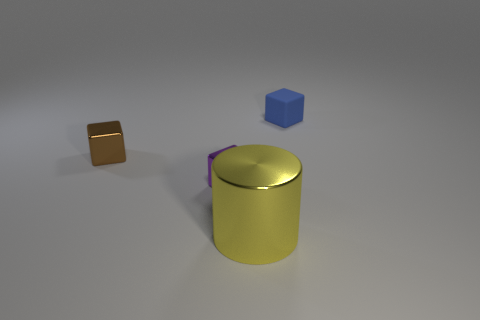Add 2 brown matte things. How many objects exist? 6 Subtract all blocks. How many objects are left? 1 Add 4 tiny shiny objects. How many tiny shiny objects are left? 6 Add 4 small cubes. How many small cubes exist? 7 Subtract 1 purple cubes. How many objects are left? 3 Subtract all large blue rubber cylinders. Subtract all blue matte objects. How many objects are left? 3 